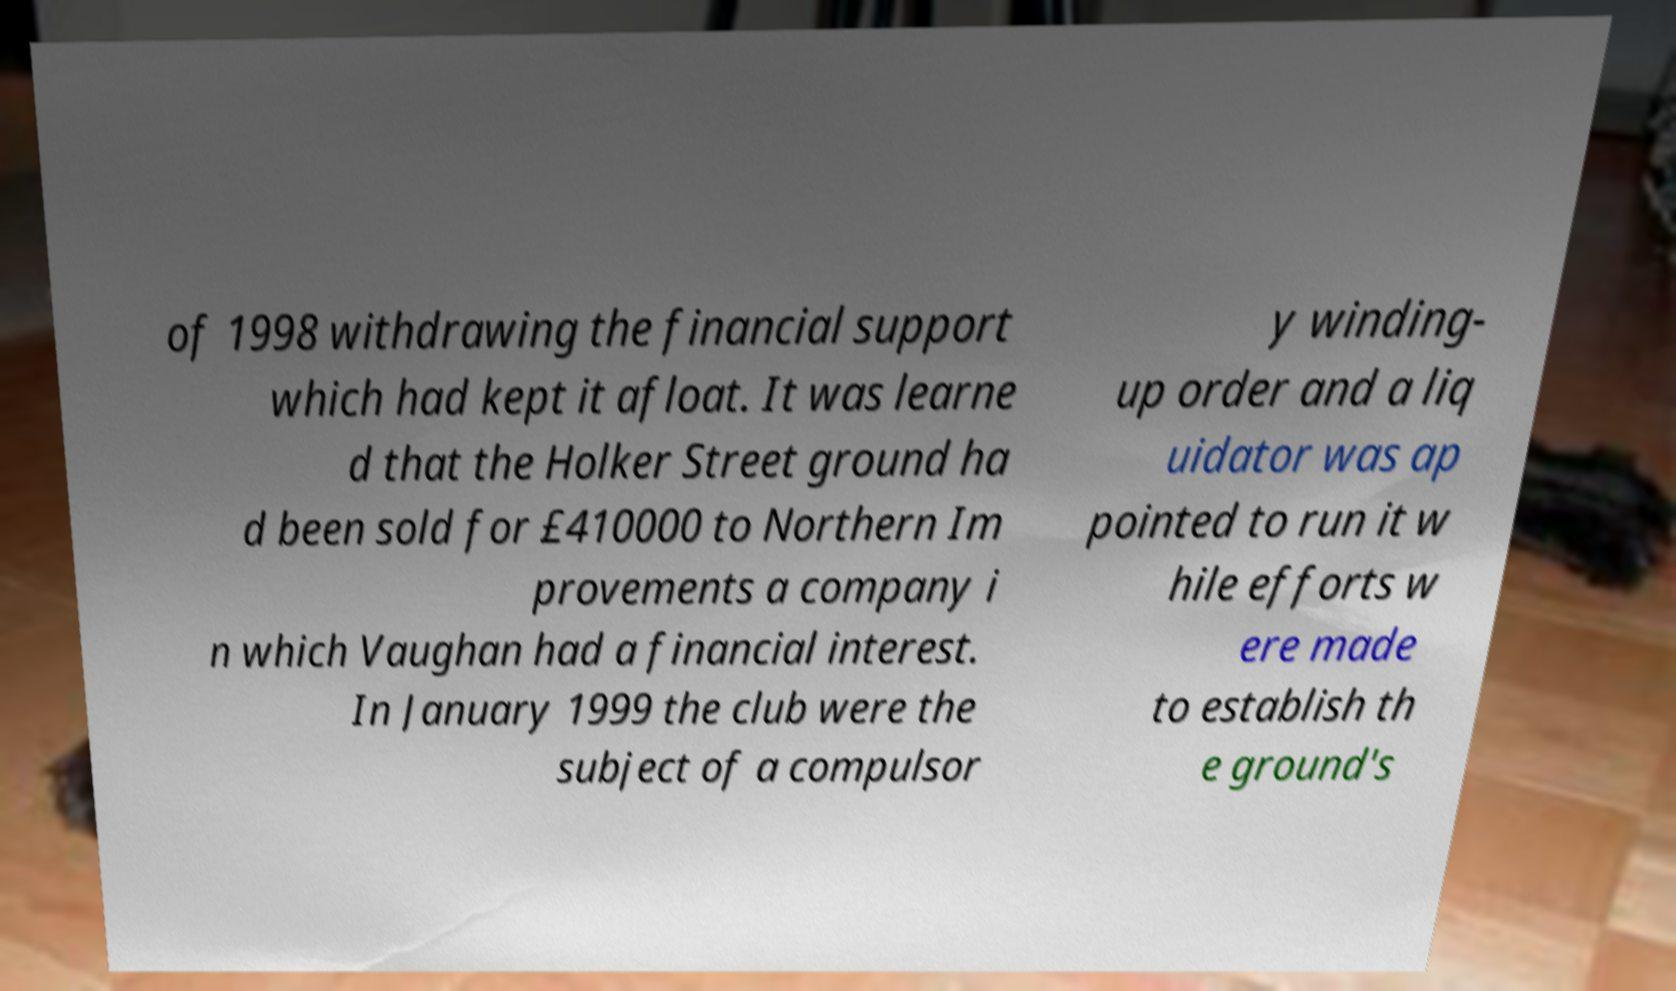Could you extract and type out the text from this image? of 1998 withdrawing the financial support which had kept it afloat. It was learne d that the Holker Street ground ha d been sold for £410000 to Northern Im provements a company i n which Vaughan had a financial interest. In January 1999 the club were the subject of a compulsor y winding- up order and a liq uidator was ap pointed to run it w hile efforts w ere made to establish th e ground's 